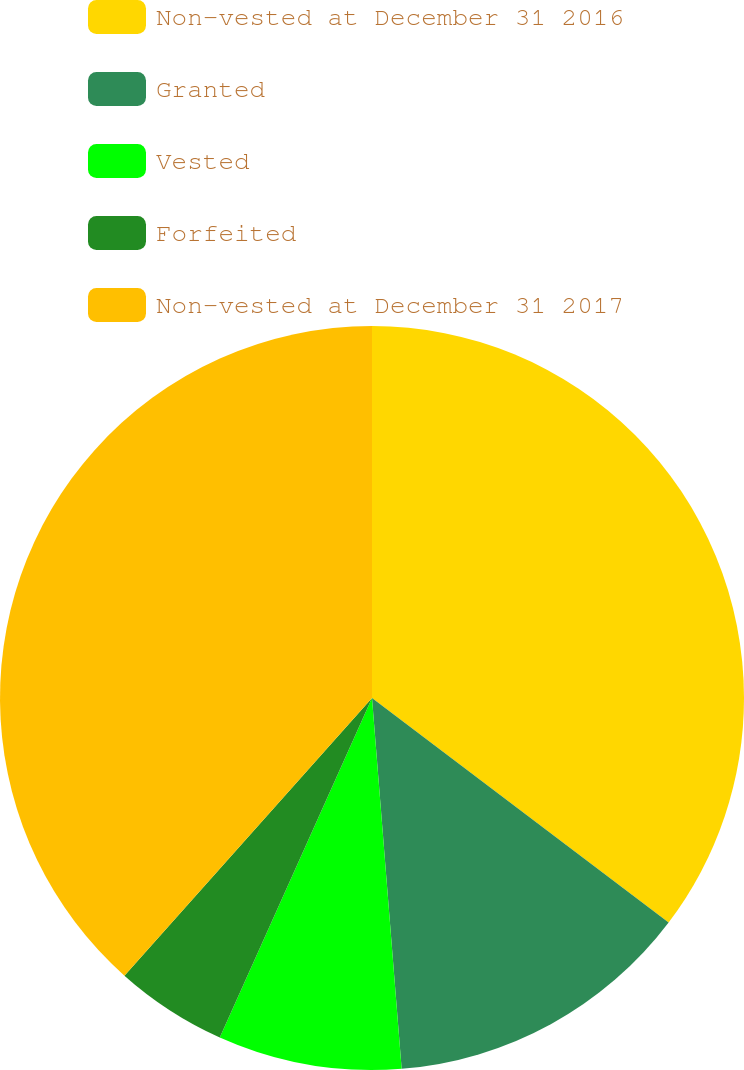<chart> <loc_0><loc_0><loc_500><loc_500><pie_chart><fcel>Non-vested at December 31 2016<fcel>Granted<fcel>Vested<fcel>Forfeited<fcel>Non-vested at December 31 2017<nl><fcel>35.31%<fcel>13.42%<fcel>7.98%<fcel>4.88%<fcel>38.41%<nl></chart> 